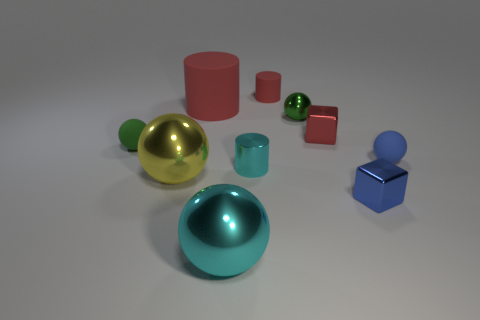How big is the ball that is right of the metal cylinder and to the left of the blue shiny thing?
Your answer should be very brief. Small. Is the number of tiny green metallic things behind the blue matte ball greater than the number of small rubber things on the left side of the red metallic object?
Make the answer very short. No. There is a big red object; is its shape the same as the red rubber thing that is right of the tiny cyan cylinder?
Keep it short and to the point. Yes. What number of other objects are there of the same shape as the small cyan metallic object?
Provide a succinct answer. 2. What is the color of the ball that is on the right side of the big cyan thing and in front of the tiny green rubber thing?
Your answer should be very brief. Blue. What is the color of the small metallic cylinder?
Give a very brief answer. Cyan. Do the cyan cylinder and the green sphere right of the small green matte sphere have the same material?
Provide a succinct answer. Yes. What shape is the tiny red object that is the same material as the cyan cylinder?
Provide a short and direct response. Cube. The other matte sphere that is the same size as the green rubber ball is what color?
Ensure brevity in your answer.  Blue. There is a green sphere left of the yellow thing; is it the same size as the blue cube?
Your answer should be very brief. Yes. 